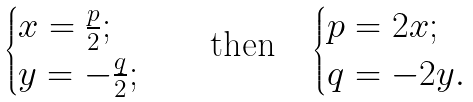<formula> <loc_0><loc_0><loc_500><loc_500>\begin{cases} x = \frac { p } { 2 } ; \\ y = - \frac { q } { 2 } ; \end{cases} \quad \text {then} \quad \begin{cases} p = 2 x ; \\ q = - 2 y . \end{cases}</formula> 